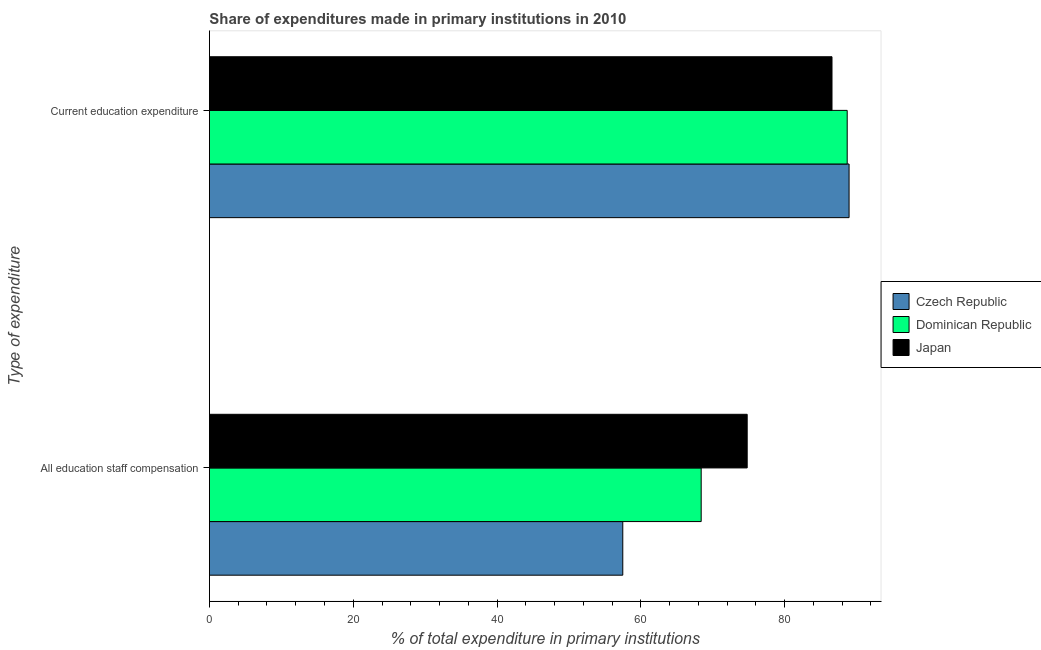How many bars are there on the 1st tick from the top?
Offer a very short reply. 3. How many bars are there on the 1st tick from the bottom?
Ensure brevity in your answer.  3. What is the label of the 1st group of bars from the top?
Offer a terse response. Current education expenditure. What is the expenditure in education in Japan?
Keep it short and to the point. 86.58. Across all countries, what is the maximum expenditure in staff compensation?
Provide a short and direct response. 74.79. Across all countries, what is the minimum expenditure in education?
Provide a short and direct response. 86.58. In which country was the expenditure in education maximum?
Your answer should be compact. Czech Republic. In which country was the expenditure in education minimum?
Offer a terse response. Japan. What is the total expenditure in staff compensation in the graph?
Make the answer very short. 200.66. What is the difference between the expenditure in education in Czech Republic and that in Japan?
Your response must be concise. 2.37. What is the difference between the expenditure in staff compensation in Japan and the expenditure in education in Czech Republic?
Make the answer very short. -14.17. What is the average expenditure in education per country?
Your answer should be compact. 88.08. What is the difference between the expenditure in education and expenditure in staff compensation in Japan?
Offer a very short reply. 11.79. In how many countries, is the expenditure in staff compensation greater than 48 %?
Your answer should be compact. 3. What is the ratio of the expenditure in education in Czech Republic to that in Dominican Republic?
Keep it short and to the point. 1. Are all the bars in the graph horizontal?
Ensure brevity in your answer.  Yes. How many countries are there in the graph?
Make the answer very short. 3. What is the difference between two consecutive major ticks on the X-axis?
Your answer should be very brief. 20. Does the graph contain grids?
Provide a short and direct response. No. What is the title of the graph?
Your answer should be compact. Share of expenditures made in primary institutions in 2010. Does "Europe(developing only)" appear as one of the legend labels in the graph?
Make the answer very short. No. What is the label or title of the X-axis?
Offer a terse response. % of total expenditure in primary institutions. What is the label or title of the Y-axis?
Give a very brief answer. Type of expenditure. What is the % of total expenditure in primary institutions of Czech Republic in All education staff compensation?
Provide a short and direct response. 57.49. What is the % of total expenditure in primary institutions in Dominican Republic in All education staff compensation?
Offer a very short reply. 68.39. What is the % of total expenditure in primary institutions in Japan in All education staff compensation?
Provide a short and direct response. 74.79. What is the % of total expenditure in primary institutions in Czech Republic in Current education expenditure?
Keep it short and to the point. 88.95. What is the % of total expenditure in primary institutions of Dominican Republic in Current education expenditure?
Your response must be concise. 88.69. What is the % of total expenditure in primary institutions of Japan in Current education expenditure?
Make the answer very short. 86.58. Across all Type of expenditure, what is the maximum % of total expenditure in primary institutions in Czech Republic?
Make the answer very short. 88.95. Across all Type of expenditure, what is the maximum % of total expenditure in primary institutions of Dominican Republic?
Make the answer very short. 88.69. Across all Type of expenditure, what is the maximum % of total expenditure in primary institutions of Japan?
Your answer should be compact. 86.58. Across all Type of expenditure, what is the minimum % of total expenditure in primary institutions of Czech Republic?
Your response must be concise. 57.49. Across all Type of expenditure, what is the minimum % of total expenditure in primary institutions of Dominican Republic?
Provide a succinct answer. 68.39. Across all Type of expenditure, what is the minimum % of total expenditure in primary institutions in Japan?
Your answer should be compact. 74.79. What is the total % of total expenditure in primary institutions in Czech Republic in the graph?
Offer a terse response. 146.44. What is the total % of total expenditure in primary institutions in Dominican Republic in the graph?
Provide a succinct answer. 157.08. What is the total % of total expenditure in primary institutions in Japan in the graph?
Ensure brevity in your answer.  161.37. What is the difference between the % of total expenditure in primary institutions in Czech Republic in All education staff compensation and that in Current education expenditure?
Your answer should be very brief. -31.47. What is the difference between the % of total expenditure in primary institutions of Dominican Republic in All education staff compensation and that in Current education expenditure?
Keep it short and to the point. -20.31. What is the difference between the % of total expenditure in primary institutions in Japan in All education staff compensation and that in Current education expenditure?
Ensure brevity in your answer.  -11.79. What is the difference between the % of total expenditure in primary institutions of Czech Republic in All education staff compensation and the % of total expenditure in primary institutions of Dominican Republic in Current education expenditure?
Offer a very short reply. -31.21. What is the difference between the % of total expenditure in primary institutions of Czech Republic in All education staff compensation and the % of total expenditure in primary institutions of Japan in Current education expenditure?
Make the answer very short. -29.1. What is the difference between the % of total expenditure in primary institutions in Dominican Republic in All education staff compensation and the % of total expenditure in primary institutions in Japan in Current education expenditure?
Keep it short and to the point. -18.19. What is the average % of total expenditure in primary institutions in Czech Republic per Type of expenditure?
Your response must be concise. 73.22. What is the average % of total expenditure in primary institutions in Dominican Republic per Type of expenditure?
Keep it short and to the point. 78.54. What is the average % of total expenditure in primary institutions in Japan per Type of expenditure?
Keep it short and to the point. 80.68. What is the difference between the % of total expenditure in primary institutions of Czech Republic and % of total expenditure in primary institutions of Dominican Republic in All education staff compensation?
Your response must be concise. -10.9. What is the difference between the % of total expenditure in primary institutions in Czech Republic and % of total expenditure in primary institutions in Japan in All education staff compensation?
Your response must be concise. -17.3. What is the difference between the % of total expenditure in primary institutions of Dominican Republic and % of total expenditure in primary institutions of Japan in All education staff compensation?
Provide a succinct answer. -6.4. What is the difference between the % of total expenditure in primary institutions in Czech Republic and % of total expenditure in primary institutions in Dominican Republic in Current education expenditure?
Make the answer very short. 0.26. What is the difference between the % of total expenditure in primary institutions of Czech Republic and % of total expenditure in primary institutions of Japan in Current education expenditure?
Make the answer very short. 2.37. What is the difference between the % of total expenditure in primary institutions in Dominican Republic and % of total expenditure in primary institutions in Japan in Current education expenditure?
Offer a terse response. 2.11. What is the ratio of the % of total expenditure in primary institutions of Czech Republic in All education staff compensation to that in Current education expenditure?
Ensure brevity in your answer.  0.65. What is the ratio of the % of total expenditure in primary institutions of Dominican Republic in All education staff compensation to that in Current education expenditure?
Make the answer very short. 0.77. What is the ratio of the % of total expenditure in primary institutions in Japan in All education staff compensation to that in Current education expenditure?
Offer a terse response. 0.86. What is the difference between the highest and the second highest % of total expenditure in primary institutions of Czech Republic?
Offer a terse response. 31.47. What is the difference between the highest and the second highest % of total expenditure in primary institutions in Dominican Republic?
Offer a terse response. 20.31. What is the difference between the highest and the second highest % of total expenditure in primary institutions of Japan?
Offer a terse response. 11.79. What is the difference between the highest and the lowest % of total expenditure in primary institutions in Czech Republic?
Offer a very short reply. 31.47. What is the difference between the highest and the lowest % of total expenditure in primary institutions of Dominican Republic?
Your answer should be very brief. 20.31. What is the difference between the highest and the lowest % of total expenditure in primary institutions of Japan?
Make the answer very short. 11.79. 